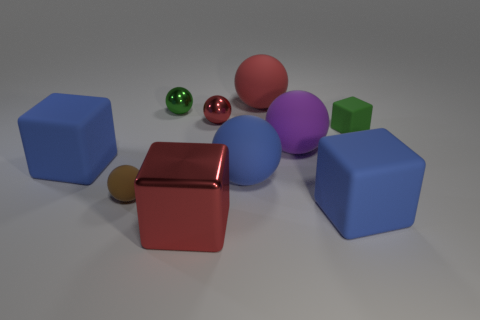Subtract all large blue matte balls. How many balls are left? 5 Subtract 1 blocks. How many blocks are left? 3 Subtract all red spheres. How many blue blocks are left? 2 Subtract all blue balls. How many balls are left? 5 Subtract all cyan cubes. Subtract all gray balls. How many cubes are left? 4 Subtract all spheres. How many objects are left? 4 Subtract all brown matte spheres. Subtract all large red matte spheres. How many objects are left? 8 Add 5 big red objects. How many big red objects are left? 7 Add 2 small metal things. How many small metal things exist? 4 Subtract 1 green blocks. How many objects are left? 9 